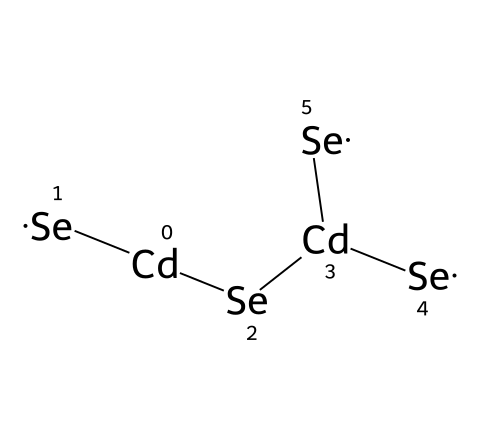What are the primary elements present in the chemical structure? The SMILES representation indicates the presence of cadmium (Cd) and selenium (Se). Both elements are explicitly mentioned, and we can sum them up as the main constituents of the structure.
Answer: cadmium and selenium How many cadmium atoms are present in the structure? By analyzing the SMILES, we see that there are two distinct occurrences of [Cd], indicating a total of two cadmium atoms in the structure.
Answer: two What type of bonding is likely present between cadmium and selenium in this compound? The structure consists of cadmium (Cd) and selenium (Se) atoms in a clustered arrangement, suggesting that they are likely bonded through ionic or covalent bonds due to the nature of these elements and their interactions in quantum dot formation.
Answer: ionic or covalent How many selenium atoms are present in the structure? Counting the occurrences of [Se] in the SMILES shows that there are four instances of selenium atoms. Therefore, there are four selenium atoms present in the chemical structure.
Answer: four What structural feature indicates this compound is a quantum dot? Quantum dots typically have a semiconductor core made from elements like cadmium and selenium; the combination and arrangement in this structure, along with the properties they exhibit (like size-dependent optical properties), characterize it as a quantum dot.
Answer: semiconductor core What is the significance of the arrangement of elements in cadmium selenide quantum dots? The arrangement and bonding of cadmium and selenium contribute to the electronic properties of quantum dots, influencing their light absorption, emission properties, and overall effectiveness for environmental sensing applications.
Answer: electronic properties 